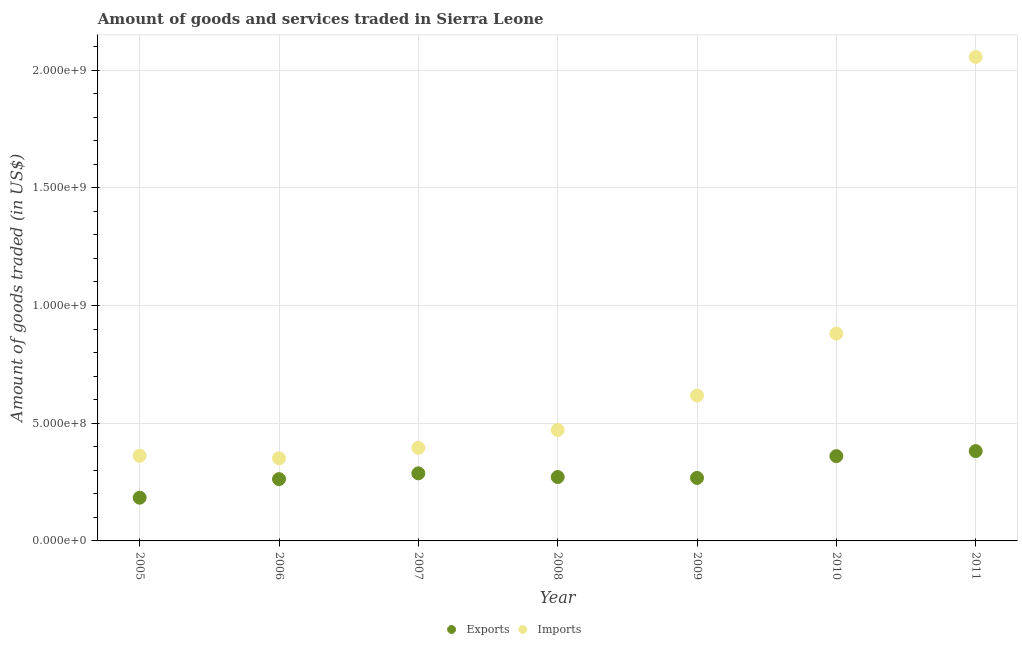How many different coloured dotlines are there?
Offer a very short reply. 2. Is the number of dotlines equal to the number of legend labels?
Your answer should be compact. Yes. What is the amount of goods imported in 2007?
Your response must be concise. 3.95e+08. Across all years, what is the maximum amount of goods exported?
Give a very brief answer. 3.82e+08. Across all years, what is the minimum amount of goods imported?
Give a very brief answer. 3.51e+08. In which year was the amount of goods exported maximum?
Offer a very short reply. 2011. In which year was the amount of goods exported minimum?
Ensure brevity in your answer.  2005. What is the total amount of goods exported in the graph?
Keep it short and to the point. 2.01e+09. What is the difference between the amount of goods imported in 2010 and that in 2011?
Your answer should be compact. -1.18e+09. What is the difference between the amount of goods imported in 2011 and the amount of goods exported in 2010?
Offer a terse response. 1.70e+09. What is the average amount of goods exported per year?
Provide a succinct answer. 2.88e+08. In the year 2006, what is the difference between the amount of goods exported and amount of goods imported?
Your response must be concise. -8.87e+07. In how many years, is the amount of goods imported greater than 500000000 US$?
Give a very brief answer. 3. What is the ratio of the amount of goods exported in 2006 to that in 2009?
Make the answer very short. 0.98. Is the amount of goods exported in 2006 less than that in 2009?
Offer a very short reply. Yes. What is the difference between the highest and the second highest amount of goods exported?
Make the answer very short. 2.14e+07. What is the difference between the highest and the lowest amount of goods exported?
Your answer should be very brief. 1.98e+08. Is the sum of the amount of goods exported in 2009 and 2010 greater than the maximum amount of goods imported across all years?
Your answer should be compact. No. Is the amount of goods imported strictly greater than the amount of goods exported over the years?
Offer a terse response. Yes. Does the graph contain any zero values?
Make the answer very short. No. Does the graph contain grids?
Provide a short and direct response. Yes. Where does the legend appear in the graph?
Keep it short and to the point. Bottom center. How are the legend labels stacked?
Provide a succinct answer. Horizontal. What is the title of the graph?
Keep it short and to the point. Amount of goods and services traded in Sierra Leone. What is the label or title of the X-axis?
Provide a short and direct response. Year. What is the label or title of the Y-axis?
Your answer should be compact. Amount of goods traded (in US$). What is the Amount of goods traded (in US$) in Exports in 2005?
Offer a very short reply. 1.84e+08. What is the Amount of goods traded (in US$) of Imports in 2005?
Make the answer very short. 3.62e+08. What is the Amount of goods traded (in US$) of Exports in 2006?
Offer a very short reply. 2.62e+08. What is the Amount of goods traded (in US$) in Imports in 2006?
Your answer should be compact. 3.51e+08. What is the Amount of goods traded (in US$) of Exports in 2007?
Provide a short and direct response. 2.87e+08. What is the Amount of goods traded (in US$) in Imports in 2007?
Provide a short and direct response. 3.95e+08. What is the Amount of goods traded (in US$) in Exports in 2008?
Give a very brief answer. 2.71e+08. What is the Amount of goods traded (in US$) in Imports in 2008?
Your answer should be compact. 4.71e+08. What is the Amount of goods traded (in US$) of Exports in 2009?
Your response must be concise. 2.68e+08. What is the Amount of goods traded (in US$) of Imports in 2009?
Offer a very short reply. 6.18e+08. What is the Amount of goods traded (in US$) in Exports in 2010?
Your answer should be compact. 3.60e+08. What is the Amount of goods traded (in US$) in Imports in 2010?
Provide a succinct answer. 8.81e+08. What is the Amount of goods traded (in US$) in Exports in 2011?
Your answer should be very brief. 3.82e+08. What is the Amount of goods traded (in US$) in Imports in 2011?
Offer a terse response. 2.06e+09. Across all years, what is the maximum Amount of goods traded (in US$) of Exports?
Keep it short and to the point. 3.82e+08. Across all years, what is the maximum Amount of goods traded (in US$) of Imports?
Give a very brief answer. 2.06e+09. Across all years, what is the minimum Amount of goods traded (in US$) in Exports?
Ensure brevity in your answer.  1.84e+08. Across all years, what is the minimum Amount of goods traded (in US$) in Imports?
Provide a short and direct response. 3.51e+08. What is the total Amount of goods traded (in US$) in Exports in the graph?
Ensure brevity in your answer.  2.01e+09. What is the total Amount of goods traded (in US$) of Imports in the graph?
Your answer should be compact. 5.13e+09. What is the difference between the Amount of goods traded (in US$) in Exports in 2005 and that in 2006?
Offer a very short reply. -7.89e+07. What is the difference between the Amount of goods traded (in US$) of Imports in 2005 and that in 2006?
Keep it short and to the point. 1.05e+07. What is the difference between the Amount of goods traded (in US$) of Exports in 2005 and that in 2007?
Provide a short and direct response. -1.04e+08. What is the difference between the Amount of goods traded (in US$) of Imports in 2005 and that in 2007?
Keep it short and to the point. -3.38e+07. What is the difference between the Amount of goods traded (in US$) in Exports in 2005 and that in 2008?
Offer a very short reply. -8.79e+07. What is the difference between the Amount of goods traded (in US$) in Imports in 2005 and that in 2008?
Offer a very short reply. -1.10e+08. What is the difference between the Amount of goods traded (in US$) in Exports in 2005 and that in 2009?
Your answer should be compact. -8.40e+07. What is the difference between the Amount of goods traded (in US$) of Imports in 2005 and that in 2009?
Offer a terse response. -2.56e+08. What is the difference between the Amount of goods traded (in US$) in Exports in 2005 and that in 2010?
Provide a short and direct response. -1.77e+08. What is the difference between the Amount of goods traded (in US$) in Imports in 2005 and that in 2010?
Your answer should be compact. -5.19e+08. What is the difference between the Amount of goods traded (in US$) of Exports in 2005 and that in 2011?
Your answer should be very brief. -1.98e+08. What is the difference between the Amount of goods traded (in US$) in Imports in 2005 and that in 2011?
Offer a very short reply. -1.69e+09. What is the difference between the Amount of goods traded (in US$) in Exports in 2006 and that in 2007?
Your answer should be very brief. -2.47e+07. What is the difference between the Amount of goods traded (in US$) of Imports in 2006 and that in 2007?
Your response must be concise. -4.43e+07. What is the difference between the Amount of goods traded (in US$) of Exports in 2006 and that in 2008?
Give a very brief answer. -9.00e+06. What is the difference between the Amount of goods traded (in US$) of Imports in 2006 and that in 2008?
Your answer should be very brief. -1.20e+08. What is the difference between the Amount of goods traded (in US$) in Exports in 2006 and that in 2009?
Provide a short and direct response. -5.16e+06. What is the difference between the Amount of goods traded (in US$) in Imports in 2006 and that in 2009?
Ensure brevity in your answer.  -2.66e+08. What is the difference between the Amount of goods traded (in US$) in Exports in 2006 and that in 2010?
Give a very brief answer. -9.77e+07. What is the difference between the Amount of goods traded (in US$) of Imports in 2006 and that in 2010?
Your answer should be very brief. -5.30e+08. What is the difference between the Amount of goods traded (in US$) of Exports in 2006 and that in 2011?
Keep it short and to the point. -1.19e+08. What is the difference between the Amount of goods traded (in US$) of Imports in 2006 and that in 2011?
Your answer should be compact. -1.70e+09. What is the difference between the Amount of goods traded (in US$) of Exports in 2007 and that in 2008?
Make the answer very short. 1.57e+07. What is the difference between the Amount of goods traded (in US$) in Imports in 2007 and that in 2008?
Provide a short and direct response. -7.58e+07. What is the difference between the Amount of goods traded (in US$) of Exports in 2007 and that in 2009?
Offer a terse response. 1.95e+07. What is the difference between the Amount of goods traded (in US$) in Imports in 2007 and that in 2009?
Make the answer very short. -2.22e+08. What is the difference between the Amount of goods traded (in US$) of Exports in 2007 and that in 2010?
Give a very brief answer. -7.30e+07. What is the difference between the Amount of goods traded (in US$) of Imports in 2007 and that in 2010?
Offer a very short reply. -4.85e+08. What is the difference between the Amount of goods traded (in US$) of Exports in 2007 and that in 2011?
Make the answer very short. -9.44e+07. What is the difference between the Amount of goods traded (in US$) of Imports in 2007 and that in 2011?
Offer a very short reply. -1.66e+09. What is the difference between the Amount of goods traded (in US$) of Exports in 2008 and that in 2009?
Keep it short and to the point. 3.85e+06. What is the difference between the Amount of goods traded (in US$) in Imports in 2008 and that in 2009?
Offer a terse response. -1.46e+08. What is the difference between the Amount of goods traded (in US$) in Exports in 2008 and that in 2010?
Ensure brevity in your answer.  -8.87e+07. What is the difference between the Amount of goods traded (in US$) in Imports in 2008 and that in 2010?
Your answer should be very brief. -4.10e+08. What is the difference between the Amount of goods traded (in US$) of Exports in 2008 and that in 2011?
Make the answer very short. -1.10e+08. What is the difference between the Amount of goods traded (in US$) in Imports in 2008 and that in 2011?
Provide a succinct answer. -1.58e+09. What is the difference between the Amount of goods traded (in US$) in Exports in 2009 and that in 2010?
Offer a very short reply. -9.25e+07. What is the difference between the Amount of goods traded (in US$) in Imports in 2009 and that in 2010?
Your answer should be very brief. -2.63e+08. What is the difference between the Amount of goods traded (in US$) in Exports in 2009 and that in 2011?
Provide a succinct answer. -1.14e+08. What is the difference between the Amount of goods traded (in US$) of Imports in 2009 and that in 2011?
Provide a succinct answer. -1.44e+09. What is the difference between the Amount of goods traded (in US$) in Exports in 2010 and that in 2011?
Your response must be concise. -2.14e+07. What is the difference between the Amount of goods traded (in US$) of Imports in 2010 and that in 2011?
Give a very brief answer. -1.18e+09. What is the difference between the Amount of goods traded (in US$) in Exports in 2005 and the Amount of goods traded (in US$) in Imports in 2006?
Give a very brief answer. -1.68e+08. What is the difference between the Amount of goods traded (in US$) in Exports in 2005 and the Amount of goods traded (in US$) in Imports in 2007?
Provide a succinct answer. -2.12e+08. What is the difference between the Amount of goods traded (in US$) of Exports in 2005 and the Amount of goods traded (in US$) of Imports in 2008?
Offer a terse response. -2.88e+08. What is the difference between the Amount of goods traded (in US$) in Exports in 2005 and the Amount of goods traded (in US$) in Imports in 2009?
Give a very brief answer. -4.34e+08. What is the difference between the Amount of goods traded (in US$) of Exports in 2005 and the Amount of goods traded (in US$) of Imports in 2010?
Make the answer very short. -6.97e+08. What is the difference between the Amount of goods traded (in US$) in Exports in 2005 and the Amount of goods traded (in US$) in Imports in 2011?
Provide a short and direct response. -1.87e+09. What is the difference between the Amount of goods traded (in US$) in Exports in 2006 and the Amount of goods traded (in US$) in Imports in 2007?
Give a very brief answer. -1.33e+08. What is the difference between the Amount of goods traded (in US$) of Exports in 2006 and the Amount of goods traded (in US$) of Imports in 2008?
Keep it short and to the point. -2.09e+08. What is the difference between the Amount of goods traded (in US$) of Exports in 2006 and the Amount of goods traded (in US$) of Imports in 2009?
Give a very brief answer. -3.55e+08. What is the difference between the Amount of goods traded (in US$) of Exports in 2006 and the Amount of goods traded (in US$) of Imports in 2010?
Provide a succinct answer. -6.18e+08. What is the difference between the Amount of goods traded (in US$) in Exports in 2006 and the Amount of goods traded (in US$) in Imports in 2011?
Your answer should be very brief. -1.79e+09. What is the difference between the Amount of goods traded (in US$) in Exports in 2007 and the Amount of goods traded (in US$) in Imports in 2008?
Offer a terse response. -1.84e+08. What is the difference between the Amount of goods traded (in US$) in Exports in 2007 and the Amount of goods traded (in US$) in Imports in 2009?
Provide a short and direct response. -3.30e+08. What is the difference between the Amount of goods traded (in US$) in Exports in 2007 and the Amount of goods traded (in US$) in Imports in 2010?
Offer a very short reply. -5.94e+08. What is the difference between the Amount of goods traded (in US$) in Exports in 2007 and the Amount of goods traded (in US$) in Imports in 2011?
Ensure brevity in your answer.  -1.77e+09. What is the difference between the Amount of goods traded (in US$) in Exports in 2008 and the Amount of goods traded (in US$) in Imports in 2009?
Your answer should be very brief. -3.46e+08. What is the difference between the Amount of goods traded (in US$) of Exports in 2008 and the Amount of goods traded (in US$) of Imports in 2010?
Offer a very short reply. -6.09e+08. What is the difference between the Amount of goods traded (in US$) of Exports in 2008 and the Amount of goods traded (in US$) of Imports in 2011?
Your answer should be compact. -1.78e+09. What is the difference between the Amount of goods traded (in US$) of Exports in 2009 and the Amount of goods traded (in US$) of Imports in 2010?
Ensure brevity in your answer.  -6.13e+08. What is the difference between the Amount of goods traded (in US$) of Exports in 2009 and the Amount of goods traded (in US$) of Imports in 2011?
Your answer should be compact. -1.79e+09. What is the difference between the Amount of goods traded (in US$) of Exports in 2010 and the Amount of goods traded (in US$) of Imports in 2011?
Provide a short and direct response. -1.70e+09. What is the average Amount of goods traded (in US$) of Exports per year?
Provide a short and direct response. 2.88e+08. What is the average Amount of goods traded (in US$) of Imports per year?
Make the answer very short. 7.33e+08. In the year 2005, what is the difference between the Amount of goods traded (in US$) in Exports and Amount of goods traded (in US$) in Imports?
Your response must be concise. -1.78e+08. In the year 2006, what is the difference between the Amount of goods traded (in US$) of Exports and Amount of goods traded (in US$) of Imports?
Offer a terse response. -8.87e+07. In the year 2007, what is the difference between the Amount of goods traded (in US$) in Exports and Amount of goods traded (in US$) in Imports?
Your response must be concise. -1.08e+08. In the year 2008, what is the difference between the Amount of goods traded (in US$) of Exports and Amount of goods traded (in US$) of Imports?
Keep it short and to the point. -2.00e+08. In the year 2009, what is the difference between the Amount of goods traded (in US$) in Exports and Amount of goods traded (in US$) in Imports?
Keep it short and to the point. -3.50e+08. In the year 2010, what is the difference between the Amount of goods traded (in US$) of Exports and Amount of goods traded (in US$) of Imports?
Your response must be concise. -5.21e+08. In the year 2011, what is the difference between the Amount of goods traded (in US$) of Exports and Amount of goods traded (in US$) of Imports?
Give a very brief answer. -1.67e+09. What is the ratio of the Amount of goods traded (in US$) in Exports in 2005 to that in 2006?
Your answer should be very brief. 0.7. What is the ratio of the Amount of goods traded (in US$) of Imports in 2005 to that in 2006?
Give a very brief answer. 1.03. What is the ratio of the Amount of goods traded (in US$) in Exports in 2005 to that in 2007?
Your answer should be compact. 0.64. What is the ratio of the Amount of goods traded (in US$) in Imports in 2005 to that in 2007?
Provide a short and direct response. 0.91. What is the ratio of the Amount of goods traded (in US$) of Exports in 2005 to that in 2008?
Provide a succinct answer. 0.68. What is the ratio of the Amount of goods traded (in US$) in Imports in 2005 to that in 2008?
Make the answer very short. 0.77. What is the ratio of the Amount of goods traded (in US$) of Exports in 2005 to that in 2009?
Your answer should be very brief. 0.69. What is the ratio of the Amount of goods traded (in US$) in Imports in 2005 to that in 2009?
Your response must be concise. 0.59. What is the ratio of the Amount of goods traded (in US$) of Exports in 2005 to that in 2010?
Offer a very short reply. 0.51. What is the ratio of the Amount of goods traded (in US$) of Imports in 2005 to that in 2010?
Provide a short and direct response. 0.41. What is the ratio of the Amount of goods traded (in US$) in Exports in 2005 to that in 2011?
Your answer should be compact. 0.48. What is the ratio of the Amount of goods traded (in US$) of Imports in 2005 to that in 2011?
Offer a terse response. 0.18. What is the ratio of the Amount of goods traded (in US$) in Exports in 2006 to that in 2007?
Your answer should be compact. 0.91. What is the ratio of the Amount of goods traded (in US$) in Imports in 2006 to that in 2007?
Offer a terse response. 0.89. What is the ratio of the Amount of goods traded (in US$) in Exports in 2006 to that in 2008?
Provide a succinct answer. 0.97. What is the ratio of the Amount of goods traded (in US$) of Imports in 2006 to that in 2008?
Make the answer very short. 0.75. What is the ratio of the Amount of goods traded (in US$) of Exports in 2006 to that in 2009?
Provide a short and direct response. 0.98. What is the ratio of the Amount of goods traded (in US$) of Imports in 2006 to that in 2009?
Your answer should be very brief. 0.57. What is the ratio of the Amount of goods traded (in US$) in Exports in 2006 to that in 2010?
Offer a very short reply. 0.73. What is the ratio of the Amount of goods traded (in US$) of Imports in 2006 to that in 2010?
Make the answer very short. 0.4. What is the ratio of the Amount of goods traded (in US$) in Exports in 2006 to that in 2011?
Your answer should be very brief. 0.69. What is the ratio of the Amount of goods traded (in US$) in Imports in 2006 to that in 2011?
Offer a terse response. 0.17. What is the ratio of the Amount of goods traded (in US$) in Exports in 2007 to that in 2008?
Your response must be concise. 1.06. What is the ratio of the Amount of goods traded (in US$) of Imports in 2007 to that in 2008?
Your answer should be compact. 0.84. What is the ratio of the Amount of goods traded (in US$) in Exports in 2007 to that in 2009?
Provide a short and direct response. 1.07. What is the ratio of the Amount of goods traded (in US$) of Imports in 2007 to that in 2009?
Make the answer very short. 0.64. What is the ratio of the Amount of goods traded (in US$) of Exports in 2007 to that in 2010?
Offer a very short reply. 0.8. What is the ratio of the Amount of goods traded (in US$) in Imports in 2007 to that in 2010?
Keep it short and to the point. 0.45. What is the ratio of the Amount of goods traded (in US$) in Exports in 2007 to that in 2011?
Offer a very short reply. 0.75. What is the ratio of the Amount of goods traded (in US$) of Imports in 2007 to that in 2011?
Your answer should be compact. 0.19. What is the ratio of the Amount of goods traded (in US$) of Exports in 2008 to that in 2009?
Your answer should be very brief. 1.01. What is the ratio of the Amount of goods traded (in US$) in Imports in 2008 to that in 2009?
Ensure brevity in your answer.  0.76. What is the ratio of the Amount of goods traded (in US$) of Exports in 2008 to that in 2010?
Offer a terse response. 0.75. What is the ratio of the Amount of goods traded (in US$) in Imports in 2008 to that in 2010?
Keep it short and to the point. 0.54. What is the ratio of the Amount of goods traded (in US$) in Exports in 2008 to that in 2011?
Your response must be concise. 0.71. What is the ratio of the Amount of goods traded (in US$) in Imports in 2008 to that in 2011?
Offer a very short reply. 0.23. What is the ratio of the Amount of goods traded (in US$) of Exports in 2009 to that in 2010?
Ensure brevity in your answer.  0.74. What is the ratio of the Amount of goods traded (in US$) of Imports in 2009 to that in 2010?
Keep it short and to the point. 0.7. What is the ratio of the Amount of goods traded (in US$) of Exports in 2009 to that in 2011?
Your answer should be very brief. 0.7. What is the ratio of the Amount of goods traded (in US$) in Imports in 2009 to that in 2011?
Your answer should be very brief. 0.3. What is the ratio of the Amount of goods traded (in US$) of Exports in 2010 to that in 2011?
Ensure brevity in your answer.  0.94. What is the ratio of the Amount of goods traded (in US$) in Imports in 2010 to that in 2011?
Provide a short and direct response. 0.43. What is the difference between the highest and the second highest Amount of goods traded (in US$) in Exports?
Your answer should be very brief. 2.14e+07. What is the difference between the highest and the second highest Amount of goods traded (in US$) of Imports?
Keep it short and to the point. 1.18e+09. What is the difference between the highest and the lowest Amount of goods traded (in US$) in Exports?
Give a very brief answer. 1.98e+08. What is the difference between the highest and the lowest Amount of goods traded (in US$) in Imports?
Provide a succinct answer. 1.70e+09. 